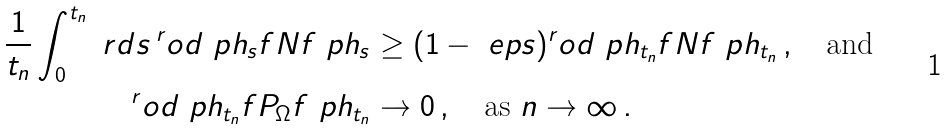<formula> <loc_0><loc_0><loc_500><loc_500>\frac { 1 } { t _ { n } } \int _ { 0 } ^ { t _ { n } } \ r d s \, ^ { r } o d { \ p h _ { s } } { f N f \ p h _ { s } } & \geq ( 1 - \ e p s ) ^ { r } o d { \ p h _ { t _ { n } } } { f N f \ p h _ { t _ { n } } } \, , \quad \text {and} \\ ^ { r } o d { \ p h _ { t _ { n } } } { f P _ { \Omega } f \ p h _ { t _ { n } } } & \to 0 \, , \quad \text {as } n \to \infty \, .</formula> 